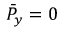Convert formula to latex. <formula><loc_0><loc_0><loc_500><loc_500>\bar { P } _ { y } = 0</formula> 